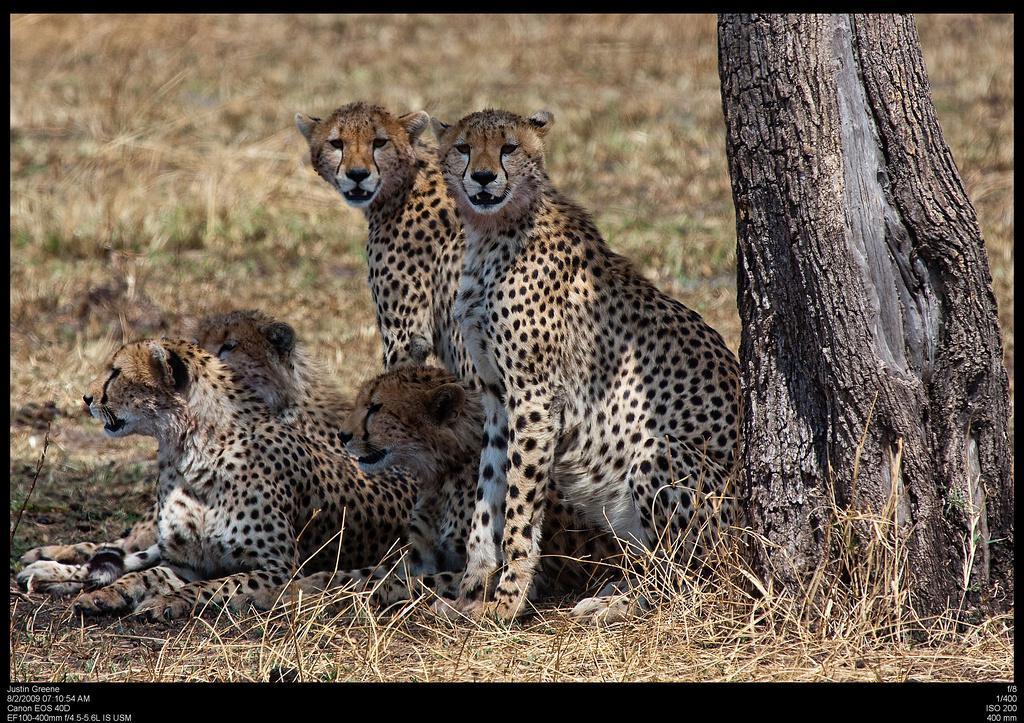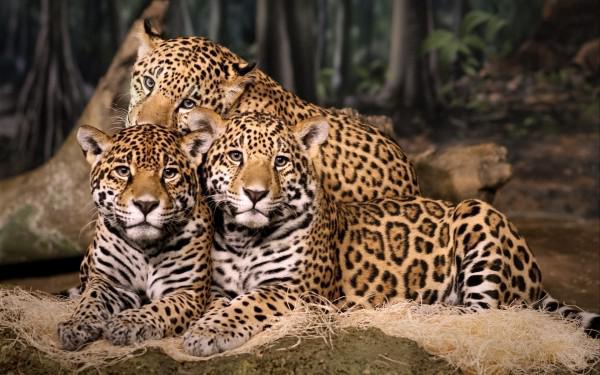The first image is the image on the left, the second image is the image on the right. Assess this claim about the two images: "the right image has three cheetas". Correct or not? Answer yes or no. Yes. The first image is the image on the left, the second image is the image on the right. Examine the images to the left and right. Is the description "In the image on the right, there are no cheetahs - instead we have leopards, with broader faces, and larger spots, without the black tear duct path the cheetahs have." accurate? Answer yes or no. Yes. 